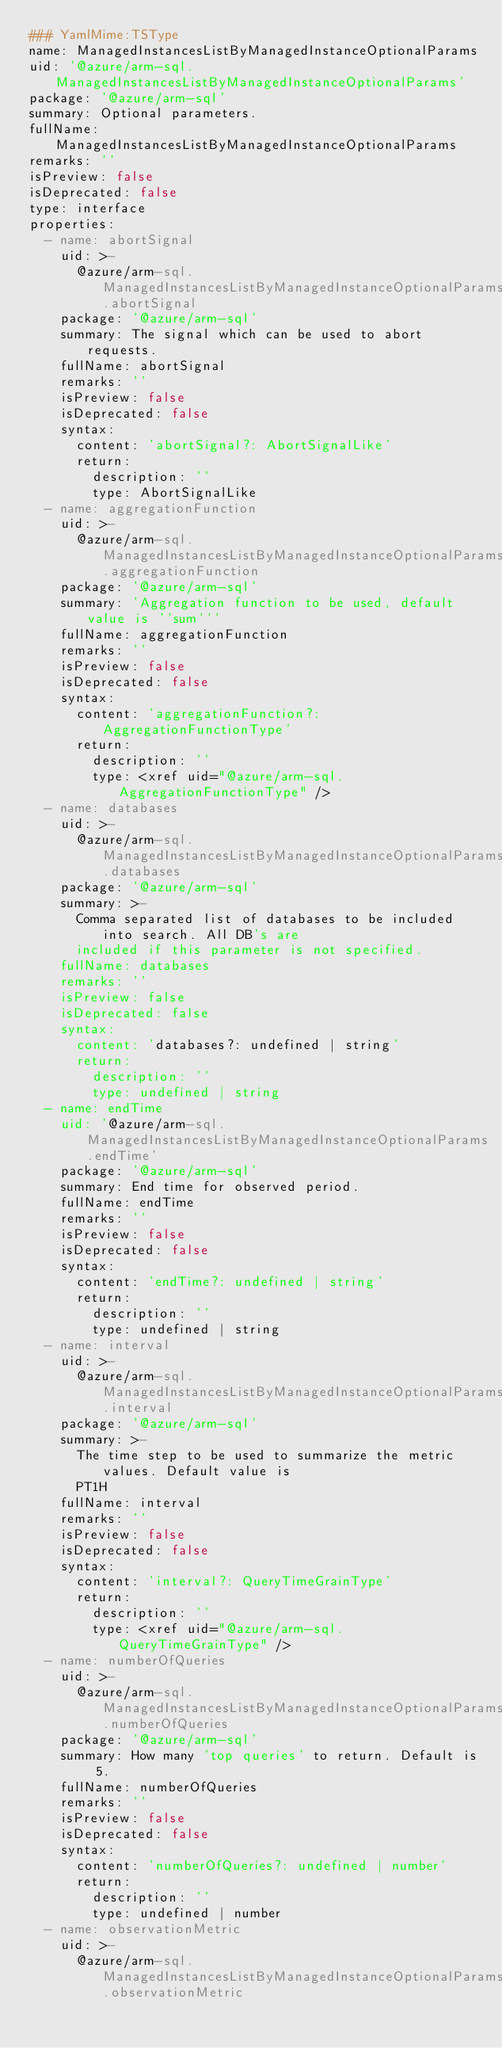<code> <loc_0><loc_0><loc_500><loc_500><_YAML_>### YamlMime:TSType
name: ManagedInstancesListByManagedInstanceOptionalParams
uid: '@azure/arm-sql.ManagedInstancesListByManagedInstanceOptionalParams'
package: '@azure/arm-sql'
summary: Optional parameters.
fullName: ManagedInstancesListByManagedInstanceOptionalParams
remarks: ''
isPreview: false
isDeprecated: false
type: interface
properties:
  - name: abortSignal
    uid: >-
      @azure/arm-sql.ManagedInstancesListByManagedInstanceOptionalParams.abortSignal
    package: '@azure/arm-sql'
    summary: The signal which can be used to abort requests.
    fullName: abortSignal
    remarks: ''
    isPreview: false
    isDeprecated: false
    syntax:
      content: 'abortSignal?: AbortSignalLike'
      return:
        description: ''
        type: AbortSignalLike
  - name: aggregationFunction
    uid: >-
      @azure/arm-sql.ManagedInstancesListByManagedInstanceOptionalParams.aggregationFunction
    package: '@azure/arm-sql'
    summary: 'Aggregation function to be used, default value is ''sum'''
    fullName: aggregationFunction
    remarks: ''
    isPreview: false
    isDeprecated: false
    syntax:
      content: 'aggregationFunction?: AggregationFunctionType'
      return:
        description: ''
        type: <xref uid="@azure/arm-sql.AggregationFunctionType" />
  - name: databases
    uid: >-
      @azure/arm-sql.ManagedInstancesListByManagedInstanceOptionalParams.databases
    package: '@azure/arm-sql'
    summary: >-
      Comma separated list of databases to be included into search. All DB's are
      included if this parameter is not specified.
    fullName: databases
    remarks: ''
    isPreview: false
    isDeprecated: false
    syntax:
      content: 'databases?: undefined | string'
      return:
        description: ''
        type: undefined | string
  - name: endTime
    uid: '@azure/arm-sql.ManagedInstancesListByManagedInstanceOptionalParams.endTime'
    package: '@azure/arm-sql'
    summary: End time for observed period.
    fullName: endTime
    remarks: ''
    isPreview: false
    isDeprecated: false
    syntax:
      content: 'endTime?: undefined | string'
      return:
        description: ''
        type: undefined | string
  - name: interval
    uid: >-
      @azure/arm-sql.ManagedInstancesListByManagedInstanceOptionalParams.interval
    package: '@azure/arm-sql'
    summary: >-
      The time step to be used to summarize the metric values. Default value is
      PT1H
    fullName: interval
    remarks: ''
    isPreview: false
    isDeprecated: false
    syntax:
      content: 'interval?: QueryTimeGrainType'
      return:
        description: ''
        type: <xref uid="@azure/arm-sql.QueryTimeGrainType" />
  - name: numberOfQueries
    uid: >-
      @azure/arm-sql.ManagedInstancesListByManagedInstanceOptionalParams.numberOfQueries
    package: '@azure/arm-sql'
    summary: How many 'top queries' to return. Default is 5.
    fullName: numberOfQueries
    remarks: ''
    isPreview: false
    isDeprecated: false
    syntax:
      content: 'numberOfQueries?: undefined | number'
      return:
        description: ''
        type: undefined | number
  - name: observationMetric
    uid: >-
      @azure/arm-sql.ManagedInstancesListByManagedInstanceOptionalParams.observationMetric</code> 